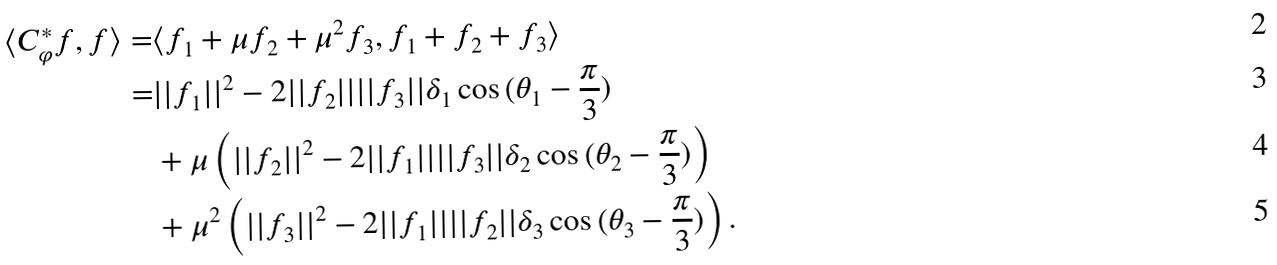Convert formula to latex. <formula><loc_0><loc_0><loc_500><loc_500>\langle C _ { \varphi } ^ { * } f , f \rangle = & \langle f _ { 1 } + \mu f _ { 2 } + \mu ^ { 2 } f _ { 3 } , f _ { 1 } + f _ { 2 } + f _ { 3 } \rangle \\ = & | | f _ { 1 } | | ^ { 2 } - 2 | | f _ { 2 } | | | | f _ { 3 } | | \delta _ { 1 } \cos { ( \theta _ { 1 } - \frac { \pi } { 3 } ) } \\ & + \mu \left ( | | f _ { 2 } | | ^ { 2 } - 2 | | f _ { 1 } | | | | f _ { 3 } | | \delta _ { 2 } \cos { ( \theta _ { 2 } - \frac { \pi } { 3 } ) } \right ) \\ & + \mu ^ { 2 } \left ( | | f _ { 3 } | | ^ { 2 } - 2 | | f _ { 1 } | | | | f _ { 2 } | | \delta _ { 3 } \cos { ( \theta _ { 3 } - \frac { \pi } { 3 } ) } \right ) .</formula> 